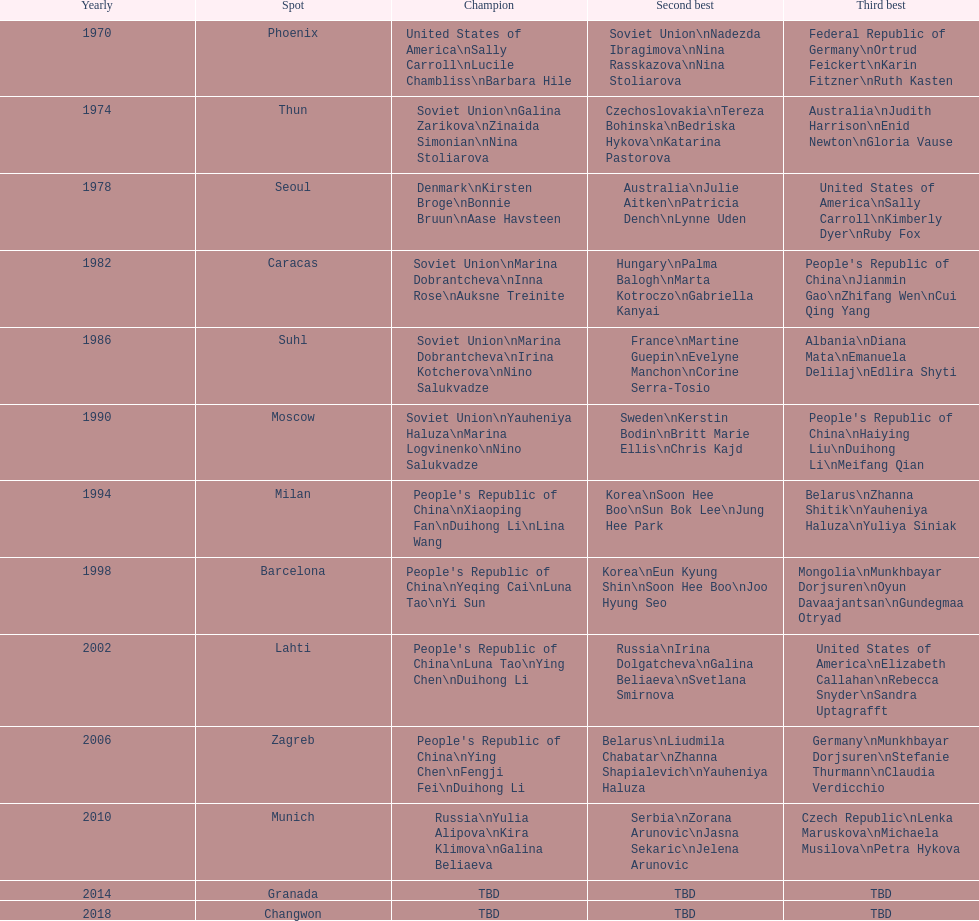Which country is listed the most under the silver column? Korea. Could you help me parse every detail presented in this table? {'header': ['Yearly', 'Spot', 'Champion', 'Second best', 'Third best'], 'rows': [['1970', 'Phoenix', 'United States of America\\nSally Carroll\\nLucile Chambliss\\nBarbara Hile', 'Soviet Union\\nNadezda Ibragimova\\nNina Rasskazova\\nNina Stoliarova', 'Federal Republic of Germany\\nOrtrud Feickert\\nKarin Fitzner\\nRuth Kasten'], ['1974', 'Thun', 'Soviet Union\\nGalina Zarikova\\nZinaida Simonian\\nNina Stoliarova', 'Czechoslovakia\\nTereza Bohinska\\nBedriska Hykova\\nKatarina Pastorova', 'Australia\\nJudith Harrison\\nEnid Newton\\nGloria Vause'], ['1978', 'Seoul', 'Denmark\\nKirsten Broge\\nBonnie Bruun\\nAase Havsteen', 'Australia\\nJulie Aitken\\nPatricia Dench\\nLynne Uden', 'United States of America\\nSally Carroll\\nKimberly Dyer\\nRuby Fox'], ['1982', 'Caracas', 'Soviet Union\\nMarina Dobrantcheva\\nInna Rose\\nAuksne Treinite', 'Hungary\\nPalma Balogh\\nMarta Kotroczo\\nGabriella Kanyai', "People's Republic of China\\nJianmin Gao\\nZhifang Wen\\nCui Qing Yang"], ['1986', 'Suhl', 'Soviet Union\\nMarina Dobrantcheva\\nIrina Kotcherova\\nNino Salukvadze', 'France\\nMartine Guepin\\nEvelyne Manchon\\nCorine Serra-Tosio', 'Albania\\nDiana Mata\\nEmanuela Delilaj\\nEdlira Shyti'], ['1990', 'Moscow', 'Soviet Union\\nYauheniya Haluza\\nMarina Logvinenko\\nNino Salukvadze', 'Sweden\\nKerstin Bodin\\nBritt Marie Ellis\\nChris Kajd', "People's Republic of China\\nHaiying Liu\\nDuihong Li\\nMeifang Qian"], ['1994', 'Milan', "People's Republic of China\\nXiaoping Fan\\nDuihong Li\\nLina Wang", 'Korea\\nSoon Hee Boo\\nSun Bok Lee\\nJung Hee Park', 'Belarus\\nZhanna Shitik\\nYauheniya Haluza\\nYuliya Siniak'], ['1998', 'Barcelona', "People's Republic of China\\nYeqing Cai\\nLuna Tao\\nYi Sun", 'Korea\\nEun Kyung Shin\\nSoon Hee Boo\\nJoo Hyung Seo', 'Mongolia\\nMunkhbayar Dorjsuren\\nOyun Davaajantsan\\nGundegmaa Otryad'], ['2002', 'Lahti', "People's Republic of China\\nLuna Tao\\nYing Chen\\nDuihong Li", 'Russia\\nIrina Dolgatcheva\\nGalina Beliaeva\\nSvetlana Smirnova', 'United States of America\\nElizabeth Callahan\\nRebecca Snyder\\nSandra Uptagrafft'], ['2006', 'Zagreb', "People's Republic of China\\nYing Chen\\nFengji Fei\\nDuihong Li", 'Belarus\\nLiudmila Chabatar\\nZhanna Shapialevich\\nYauheniya Haluza', 'Germany\\nMunkhbayar Dorjsuren\\nStefanie Thurmann\\nClaudia Verdicchio'], ['2010', 'Munich', 'Russia\\nYulia Alipova\\nKira Klimova\\nGalina Beliaeva', 'Serbia\\nZorana Arunovic\\nJasna Sekaric\\nJelena Arunovic', 'Czech Republic\\nLenka Maruskova\\nMichaela Musilova\\nPetra Hykova'], ['2014', 'Granada', 'TBD', 'TBD', 'TBD'], ['2018', 'Changwon', 'TBD', 'TBD', 'TBD']]} 